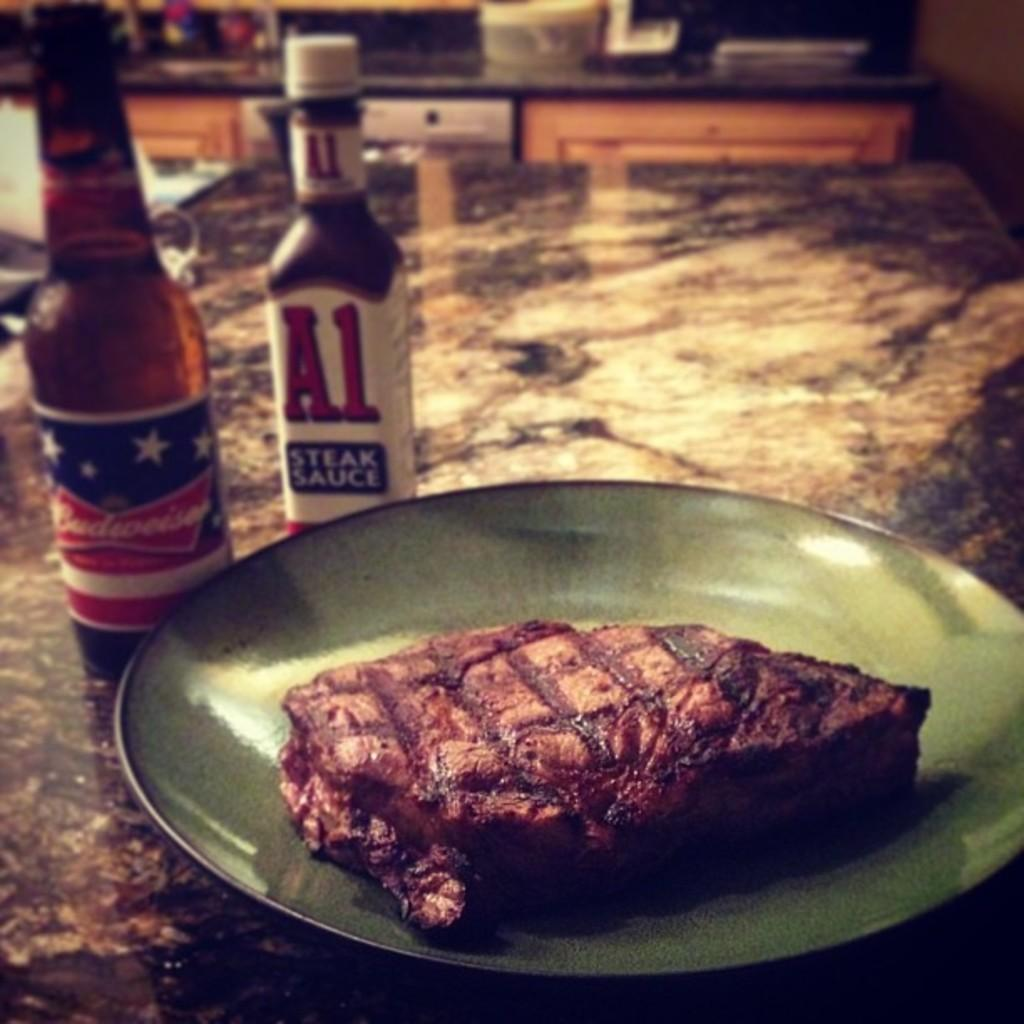Provide a one-sentence caption for the provided image. A bottle of A1 sauce is behind a plate with a steak on it. 